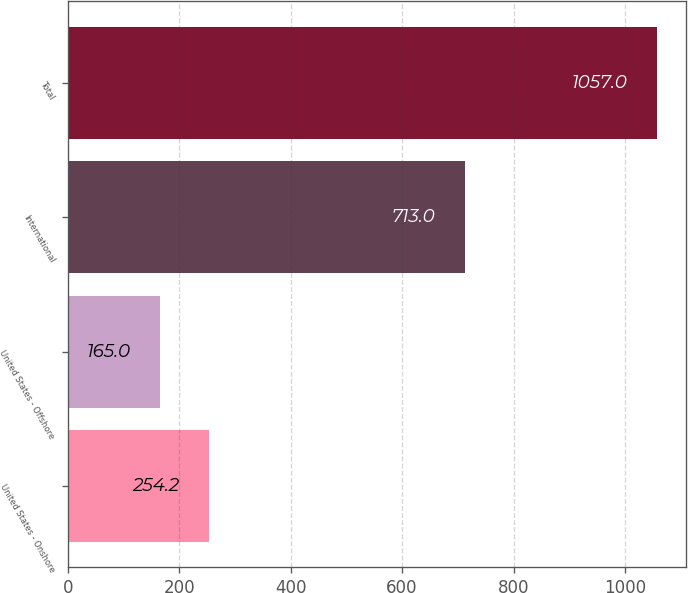Convert chart. <chart><loc_0><loc_0><loc_500><loc_500><bar_chart><fcel>United States - Onshore<fcel>United States - Offshore<fcel>International<fcel>Total<nl><fcel>254.2<fcel>165<fcel>713<fcel>1057<nl></chart> 